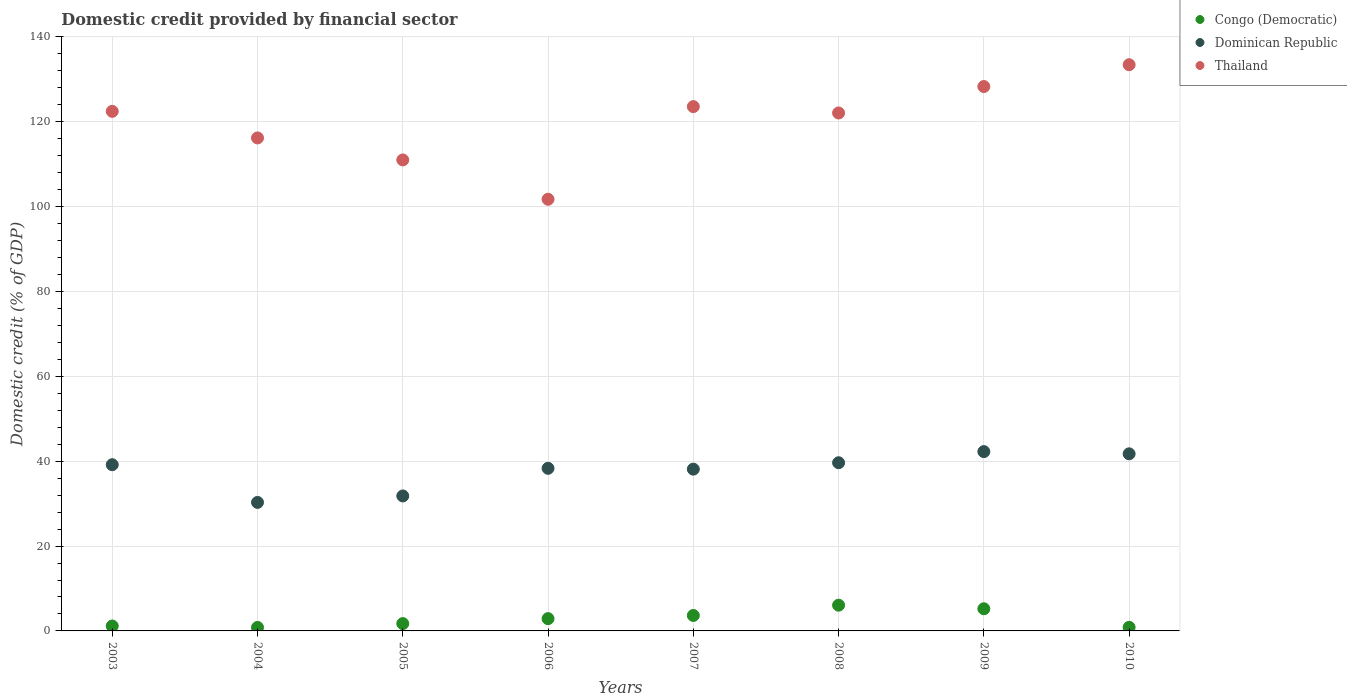What is the domestic credit in Thailand in 2003?
Your answer should be very brief. 122.47. Across all years, what is the maximum domestic credit in Dominican Republic?
Keep it short and to the point. 42.27. Across all years, what is the minimum domestic credit in Congo (Democratic)?
Offer a terse response. 0.82. In which year was the domestic credit in Thailand maximum?
Keep it short and to the point. 2010. In which year was the domestic credit in Dominican Republic minimum?
Your answer should be very brief. 2004. What is the total domestic credit in Dominican Republic in the graph?
Give a very brief answer. 301.4. What is the difference between the domestic credit in Thailand in 2008 and that in 2009?
Your answer should be very brief. -6.23. What is the difference between the domestic credit in Dominican Republic in 2003 and the domestic credit in Congo (Democratic) in 2009?
Keep it short and to the point. 33.95. What is the average domestic credit in Dominican Republic per year?
Keep it short and to the point. 37.68. In the year 2007, what is the difference between the domestic credit in Thailand and domestic credit in Dominican Republic?
Provide a short and direct response. 85.46. What is the ratio of the domestic credit in Thailand in 2007 to that in 2008?
Give a very brief answer. 1.01. Is the domestic credit in Thailand in 2007 less than that in 2008?
Make the answer very short. No. Is the difference between the domestic credit in Thailand in 2007 and 2009 greater than the difference between the domestic credit in Dominican Republic in 2007 and 2009?
Offer a terse response. No. What is the difference between the highest and the second highest domestic credit in Thailand?
Keep it short and to the point. 5.14. What is the difference between the highest and the lowest domestic credit in Congo (Democratic)?
Provide a succinct answer. 5.24. In how many years, is the domestic credit in Thailand greater than the average domestic credit in Thailand taken over all years?
Offer a very short reply. 5. Does the domestic credit in Congo (Democratic) monotonically increase over the years?
Give a very brief answer. No. How many dotlines are there?
Make the answer very short. 3. How many years are there in the graph?
Your answer should be very brief. 8. What is the title of the graph?
Your response must be concise. Domestic credit provided by financial sector. What is the label or title of the X-axis?
Keep it short and to the point. Years. What is the label or title of the Y-axis?
Your response must be concise. Domestic credit (% of GDP). What is the Domestic credit (% of GDP) of Congo (Democratic) in 2003?
Offer a very short reply. 1.16. What is the Domestic credit (% of GDP) of Dominican Republic in 2003?
Ensure brevity in your answer.  39.18. What is the Domestic credit (% of GDP) in Thailand in 2003?
Give a very brief answer. 122.47. What is the Domestic credit (% of GDP) in Congo (Democratic) in 2004?
Your answer should be compact. 0.82. What is the Domestic credit (% of GDP) in Dominican Republic in 2004?
Your answer should be compact. 30.29. What is the Domestic credit (% of GDP) in Thailand in 2004?
Keep it short and to the point. 116.21. What is the Domestic credit (% of GDP) in Congo (Democratic) in 2005?
Your answer should be very brief. 1.73. What is the Domestic credit (% of GDP) of Dominican Republic in 2005?
Offer a very short reply. 31.81. What is the Domestic credit (% of GDP) in Thailand in 2005?
Keep it short and to the point. 111.02. What is the Domestic credit (% of GDP) of Congo (Democratic) in 2006?
Offer a very short reply. 2.9. What is the Domestic credit (% of GDP) in Dominican Republic in 2006?
Offer a terse response. 38.33. What is the Domestic credit (% of GDP) of Thailand in 2006?
Provide a short and direct response. 101.75. What is the Domestic credit (% of GDP) in Congo (Democratic) in 2007?
Provide a short and direct response. 3.64. What is the Domestic credit (% of GDP) in Dominican Republic in 2007?
Give a very brief answer. 38.13. What is the Domestic credit (% of GDP) of Thailand in 2007?
Provide a short and direct response. 123.59. What is the Domestic credit (% of GDP) of Congo (Democratic) in 2008?
Your answer should be very brief. 6.06. What is the Domestic credit (% of GDP) in Dominican Republic in 2008?
Offer a very short reply. 39.64. What is the Domestic credit (% of GDP) of Thailand in 2008?
Your response must be concise. 122.09. What is the Domestic credit (% of GDP) of Congo (Democratic) in 2009?
Provide a succinct answer. 5.22. What is the Domestic credit (% of GDP) of Dominican Republic in 2009?
Ensure brevity in your answer.  42.27. What is the Domestic credit (% of GDP) in Thailand in 2009?
Provide a succinct answer. 128.32. What is the Domestic credit (% of GDP) of Congo (Democratic) in 2010?
Offer a very short reply. 0.85. What is the Domestic credit (% of GDP) of Dominican Republic in 2010?
Offer a very short reply. 41.74. What is the Domestic credit (% of GDP) of Thailand in 2010?
Your answer should be very brief. 133.46. Across all years, what is the maximum Domestic credit (% of GDP) in Congo (Democratic)?
Your answer should be compact. 6.06. Across all years, what is the maximum Domestic credit (% of GDP) of Dominican Republic?
Provide a short and direct response. 42.27. Across all years, what is the maximum Domestic credit (% of GDP) in Thailand?
Provide a short and direct response. 133.46. Across all years, what is the minimum Domestic credit (% of GDP) in Congo (Democratic)?
Provide a short and direct response. 0.82. Across all years, what is the minimum Domestic credit (% of GDP) of Dominican Republic?
Ensure brevity in your answer.  30.29. Across all years, what is the minimum Domestic credit (% of GDP) of Thailand?
Provide a short and direct response. 101.75. What is the total Domestic credit (% of GDP) of Congo (Democratic) in the graph?
Offer a terse response. 22.39. What is the total Domestic credit (% of GDP) of Dominican Republic in the graph?
Offer a terse response. 301.4. What is the total Domestic credit (% of GDP) of Thailand in the graph?
Ensure brevity in your answer.  958.91. What is the difference between the Domestic credit (% of GDP) of Congo (Democratic) in 2003 and that in 2004?
Make the answer very short. 0.34. What is the difference between the Domestic credit (% of GDP) of Dominican Republic in 2003 and that in 2004?
Offer a terse response. 8.89. What is the difference between the Domestic credit (% of GDP) in Thailand in 2003 and that in 2004?
Offer a terse response. 6.27. What is the difference between the Domestic credit (% of GDP) of Congo (Democratic) in 2003 and that in 2005?
Keep it short and to the point. -0.57. What is the difference between the Domestic credit (% of GDP) in Dominican Republic in 2003 and that in 2005?
Keep it short and to the point. 7.36. What is the difference between the Domestic credit (% of GDP) in Thailand in 2003 and that in 2005?
Your answer should be compact. 11.45. What is the difference between the Domestic credit (% of GDP) of Congo (Democratic) in 2003 and that in 2006?
Offer a terse response. -1.74. What is the difference between the Domestic credit (% of GDP) of Dominican Republic in 2003 and that in 2006?
Offer a terse response. 0.85. What is the difference between the Domestic credit (% of GDP) of Thailand in 2003 and that in 2006?
Make the answer very short. 20.72. What is the difference between the Domestic credit (% of GDP) of Congo (Democratic) in 2003 and that in 2007?
Give a very brief answer. -2.48. What is the difference between the Domestic credit (% of GDP) of Dominican Republic in 2003 and that in 2007?
Make the answer very short. 1.04. What is the difference between the Domestic credit (% of GDP) of Thailand in 2003 and that in 2007?
Your answer should be very brief. -1.12. What is the difference between the Domestic credit (% of GDP) of Congo (Democratic) in 2003 and that in 2008?
Offer a terse response. -4.9. What is the difference between the Domestic credit (% of GDP) in Dominican Republic in 2003 and that in 2008?
Ensure brevity in your answer.  -0.47. What is the difference between the Domestic credit (% of GDP) of Thailand in 2003 and that in 2008?
Provide a short and direct response. 0.38. What is the difference between the Domestic credit (% of GDP) of Congo (Democratic) in 2003 and that in 2009?
Provide a short and direct response. -4.06. What is the difference between the Domestic credit (% of GDP) in Dominican Republic in 2003 and that in 2009?
Offer a terse response. -3.09. What is the difference between the Domestic credit (% of GDP) of Thailand in 2003 and that in 2009?
Give a very brief answer. -5.85. What is the difference between the Domestic credit (% of GDP) in Congo (Democratic) in 2003 and that in 2010?
Your answer should be compact. 0.31. What is the difference between the Domestic credit (% of GDP) of Dominican Republic in 2003 and that in 2010?
Make the answer very short. -2.57. What is the difference between the Domestic credit (% of GDP) of Thailand in 2003 and that in 2010?
Your answer should be compact. -10.99. What is the difference between the Domestic credit (% of GDP) of Congo (Democratic) in 2004 and that in 2005?
Make the answer very short. -0.9. What is the difference between the Domestic credit (% of GDP) in Dominican Republic in 2004 and that in 2005?
Your answer should be very brief. -1.52. What is the difference between the Domestic credit (% of GDP) in Thailand in 2004 and that in 2005?
Your answer should be compact. 5.19. What is the difference between the Domestic credit (% of GDP) in Congo (Democratic) in 2004 and that in 2006?
Your response must be concise. -2.07. What is the difference between the Domestic credit (% of GDP) in Dominican Republic in 2004 and that in 2006?
Your answer should be compact. -8.04. What is the difference between the Domestic credit (% of GDP) of Thailand in 2004 and that in 2006?
Your response must be concise. 14.46. What is the difference between the Domestic credit (% of GDP) in Congo (Democratic) in 2004 and that in 2007?
Ensure brevity in your answer.  -2.82. What is the difference between the Domestic credit (% of GDP) in Dominican Republic in 2004 and that in 2007?
Your response must be concise. -7.84. What is the difference between the Domestic credit (% of GDP) of Thailand in 2004 and that in 2007?
Provide a short and direct response. -7.38. What is the difference between the Domestic credit (% of GDP) in Congo (Democratic) in 2004 and that in 2008?
Provide a short and direct response. -5.24. What is the difference between the Domestic credit (% of GDP) in Dominican Republic in 2004 and that in 2008?
Your answer should be very brief. -9.35. What is the difference between the Domestic credit (% of GDP) of Thailand in 2004 and that in 2008?
Make the answer very short. -5.88. What is the difference between the Domestic credit (% of GDP) in Congo (Democratic) in 2004 and that in 2009?
Ensure brevity in your answer.  -4.4. What is the difference between the Domestic credit (% of GDP) of Dominican Republic in 2004 and that in 2009?
Provide a succinct answer. -11.98. What is the difference between the Domestic credit (% of GDP) of Thailand in 2004 and that in 2009?
Provide a short and direct response. -12.12. What is the difference between the Domestic credit (% of GDP) of Congo (Democratic) in 2004 and that in 2010?
Your answer should be very brief. -0.03. What is the difference between the Domestic credit (% of GDP) in Dominican Republic in 2004 and that in 2010?
Your answer should be compact. -11.45. What is the difference between the Domestic credit (% of GDP) in Thailand in 2004 and that in 2010?
Keep it short and to the point. -17.26. What is the difference between the Domestic credit (% of GDP) in Congo (Democratic) in 2005 and that in 2006?
Ensure brevity in your answer.  -1.17. What is the difference between the Domestic credit (% of GDP) in Dominican Republic in 2005 and that in 2006?
Keep it short and to the point. -6.52. What is the difference between the Domestic credit (% of GDP) in Thailand in 2005 and that in 2006?
Keep it short and to the point. 9.27. What is the difference between the Domestic credit (% of GDP) of Congo (Democratic) in 2005 and that in 2007?
Ensure brevity in your answer.  -1.91. What is the difference between the Domestic credit (% of GDP) in Dominican Republic in 2005 and that in 2007?
Offer a terse response. -6.32. What is the difference between the Domestic credit (% of GDP) in Thailand in 2005 and that in 2007?
Keep it short and to the point. -12.57. What is the difference between the Domestic credit (% of GDP) in Congo (Democratic) in 2005 and that in 2008?
Make the answer very short. -4.34. What is the difference between the Domestic credit (% of GDP) of Dominican Republic in 2005 and that in 2008?
Offer a terse response. -7.83. What is the difference between the Domestic credit (% of GDP) of Thailand in 2005 and that in 2008?
Give a very brief answer. -11.07. What is the difference between the Domestic credit (% of GDP) in Congo (Democratic) in 2005 and that in 2009?
Offer a very short reply. -3.49. What is the difference between the Domestic credit (% of GDP) of Dominican Republic in 2005 and that in 2009?
Offer a terse response. -10.45. What is the difference between the Domestic credit (% of GDP) of Thailand in 2005 and that in 2009?
Give a very brief answer. -17.3. What is the difference between the Domestic credit (% of GDP) of Congo (Democratic) in 2005 and that in 2010?
Your answer should be very brief. 0.88. What is the difference between the Domestic credit (% of GDP) in Dominican Republic in 2005 and that in 2010?
Offer a terse response. -9.93. What is the difference between the Domestic credit (% of GDP) of Thailand in 2005 and that in 2010?
Give a very brief answer. -22.45. What is the difference between the Domestic credit (% of GDP) in Congo (Democratic) in 2006 and that in 2007?
Give a very brief answer. -0.75. What is the difference between the Domestic credit (% of GDP) of Dominican Republic in 2006 and that in 2007?
Give a very brief answer. 0.2. What is the difference between the Domestic credit (% of GDP) of Thailand in 2006 and that in 2007?
Offer a terse response. -21.84. What is the difference between the Domestic credit (% of GDP) of Congo (Democratic) in 2006 and that in 2008?
Provide a succinct answer. -3.17. What is the difference between the Domestic credit (% of GDP) of Dominican Republic in 2006 and that in 2008?
Your answer should be very brief. -1.31. What is the difference between the Domestic credit (% of GDP) in Thailand in 2006 and that in 2008?
Give a very brief answer. -20.34. What is the difference between the Domestic credit (% of GDP) of Congo (Democratic) in 2006 and that in 2009?
Provide a succinct answer. -2.33. What is the difference between the Domestic credit (% of GDP) of Dominican Republic in 2006 and that in 2009?
Make the answer very short. -3.93. What is the difference between the Domestic credit (% of GDP) in Thailand in 2006 and that in 2009?
Your answer should be compact. -26.57. What is the difference between the Domestic credit (% of GDP) in Congo (Democratic) in 2006 and that in 2010?
Provide a short and direct response. 2.05. What is the difference between the Domestic credit (% of GDP) in Dominican Republic in 2006 and that in 2010?
Offer a terse response. -3.41. What is the difference between the Domestic credit (% of GDP) of Thailand in 2006 and that in 2010?
Offer a very short reply. -31.71. What is the difference between the Domestic credit (% of GDP) in Congo (Democratic) in 2007 and that in 2008?
Make the answer very short. -2.42. What is the difference between the Domestic credit (% of GDP) of Dominican Republic in 2007 and that in 2008?
Offer a very short reply. -1.51. What is the difference between the Domestic credit (% of GDP) in Thailand in 2007 and that in 2008?
Offer a very short reply. 1.5. What is the difference between the Domestic credit (% of GDP) in Congo (Democratic) in 2007 and that in 2009?
Offer a very short reply. -1.58. What is the difference between the Domestic credit (% of GDP) in Dominican Republic in 2007 and that in 2009?
Your answer should be compact. -4.13. What is the difference between the Domestic credit (% of GDP) of Thailand in 2007 and that in 2009?
Give a very brief answer. -4.73. What is the difference between the Domestic credit (% of GDP) in Congo (Democratic) in 2007 and that in 2010?
Your answer should be very brief. 2.79. What is the difference between the Domestic credit (% of GDP) in Dominican Republic in 2007 and that in 2010?
Provide a succinct answer. -3.61. What is the difference between the Domestic credit (% of GDP) of Thailand in 2007 and that in 2010?
Keep it short and to the point. -9.87. What is the difference between the Domestic credit (% of GDP) of Congo (Democratic) in 2008 and that in 2009?
Provide a succinct answer. 0.84. What is the difference between the Domestic credit (% of GDP) in Dominican Republic in 2008 and that in 2009?
Keep it short and to the point. -2.62. What is the difference between the Domestic credit (% of GDP) of Thailand in 2008 and that in 2009?
Make the answer very short. -6.23. What is the difference between the Domestic credit (% of GDP) in Congo (Democratic) in 2008 and that in 2010?
Offer a terse response. 5.21. What is the difference between the Domestic credit (% of GDP) of Dominican Republic in 2008 and that in 2010?
Ensure brevity in your answer.  -2.1. What is the difference between the Domestic credit (% of GDP) of Thailand in 2008 and that in 2010?
Give a very brief answer. -11.37. What is the difference between the Domestic credit (% of GDP) of Congo (Democratic) in 2009 and that in 2010?
Ensure brevity in your answer.  4.37. What is the difference between the Domestic credit (% of GDP) of Dominican Republic in 2009 and that in 2010?
Make the answer very short. 0.52. What is the difference between the Domestic credit (% of GDP) in Thailand in 2009 and that in 2010?
Your answer should be compact. -5.14. What is the difference between the Domestic credit (% of GDP) in Congo (Democratic) in 2003 and the Domestic credit (% of GDP) in Dominican Republic in 2004?
Keep it short and to the point. -29.13. What is the difference between the Domestic credit (% of GDP) of Congo (Democratic) in 2003 and the Domestic credit (% of GDP) of Thailand in 2004?
Offer a very short reply. -115.05. What is the difference between the Domestic credit (% of GDP) of Dominican Republic in 2003 and the Domestic credit (% of GDP) of Thailand in 2004?
Ensure brevity in your answer.  -77.03. What is the difference between the Domestic credit (% of GDP) of Congo (Democratic) in 2003 and the Domestic credit (% of GDP) of Dominican Republic in 2005?
Provide a short and direct response. -30.65. What is the difference between the Domestic credit (% of GDP) of Congo (Democratic) in 2003 and the Domestic credit (% of GDP) of Thailand in 2005?
Your answer should be very brief. -109.86. What is the difference between the Domestic credit (% of GDP) in Dominican Republic in 2003 and the Domestic credit (% of GDP) in Thailand in 2005?
Ensure brevity in your answer.  -71.84. What is the difference between the Domestic credit (% of GDP) in Congo (Democratic) in 2003 and the Domestic credit (% of GDP) in Dominican Republic in 2006?
Provide a short and direct response. -37.17. What is the difference between the Domestic credit (% of GDP) of Congo (Democratic) in 2003 and the Domestic credit (% of GDP) of Thailand in 2006?
Make the answer very short. -100.59. What is the difference between the Domestic credit (% of GDP) in Dominican Republic in 2003 and the Domestic credit (% of GDP) in Thailand in 2006?
Your response must be concise. -62.57. What is the difference between the Domestic credit (% of GDP) in Congo (Democratic) in 2003 and the Domestic credit (% of GDP) in Dominican Republic in 2007?
Provide a succinct answer. -36.97. What is the difference between the Domestic credit (% of GDP) in Congo (Democratic) in 2003 and the Domestic credit (% of GDP) in Thailand in 2007?
Your response must be concise. -122.43. What is the difference between the Domestic credit (% of GDP) in Dominican Republic in 2003 and the Domestic credit (% of GDP) in Thailand in 2007?
Your answer should be compact. -84.41. What is the difference between the Domestic credit (% of GDP) of Congo (Democratic) in 2003 and the Domestic credit (% of GDP) of Dominican Republic in 2008?
Your response must be concise. -38.48. What is the difference between the Domestic credit (% of GDP) of Congo (Democratic) in 2003 and the Domestic credit (% of GDP) of Thailand in 2008?
Provide a succinct answer. -120.93. What is the difference between the Domestic credit (% of GDP) of Dominican Republic in 2003 and the Domestic credit (% of GDP) of Thailand in 2008?
Ensure brevity in your answer.  -82.91. What is the difference between the Domestic credit (% of GDP) of Congo (Democratic) in 2003 and the Domestic credit (% of GDP) of Dominican Republic in 2009?
Provide a short and direct response. -41.11. What is the difference between the Domestic credit (% of GDP) in Congo (Democratic) in 2003 and the Domestic credit (% of GDP) in Thailand in 2009?
Make the answer very short. -127.16. What is the difference between the Domestic credit (% of GDP) of Dominican Republic in 2003 and the Domestic credit (% of GDP) of Thailand in 2009?
Ensure brevity in your answer.  -89.14. What is the difference between the Domestic credit (% of GDP) in Congo (Democratic) in 2003 and the Domestic credit (% of GDP) in Dominican Republic in 2010?
Your answer should be very brief. -40.58. What is the difference between the Domestic credit (% of GDP) of Congo (Democratic) in 2003 and the Domestic credit (% of GDP) of Thailand in 2010?
Keep it short and to the point. -132.3. What is the difference between the Domestic credit (% of GDP) in Dominican Republic in 2003 and the Domestic credit (% of GDP) in Thailand in 2010?
Your response must be concise. -94.29. What is the difference between the Domestic credit (% of GDP) of Congo (Democratic) in 2004 and the Domestic credit (% of GDP) of Dominican Republic in 2005?
Ensure brevity in your answer.  -30.99. What is the difference between the Domestic credit (% of GDP) in Congo (Democratic) in 2004 and the Domestic credit (% of GDP) in Thailand in 2005?
Your response must be concise. -110.19. What is the difference between the Domestic credit (% of GDP) of Dominican Republic in 2004 and the Domestic credit (% of GDP) of Thailand in 2005?
Offer a terse response. -80.73. What is the difference between the Domestic credit (% of GDP) in Congo (Democratic) in 2004 and the Domestic credit (% of GDP) in Dominican Republic in 2006?
Provide a short and direct response. -37.51. What is the difference between the Domestic credit (% of GDP) of Congo (Democratic) in 2004 and the Domestic credit (% of GDP) of Thailand in 2006?
Provide a succinct answer. -100.93. What is the difference between the Domestic credit (% of GDP) of Dominican Republic in 2004 and the Domestic credit (% of GDP) of Thailand in 2006?
Offer a very short reply. -71.46. What is the difference between the Domestic credit (% of GDP) in Congo (Democratic) in 2004 and the Domestic credit (% of GDP) in Dominican Republic in 2007?
Your answer should be very brief. -37.31. What is the difference between the Domestic credit (% of GDP) of Congo (Democratic) in 2004 and the Domestic credit (% of GDP) of Thailand in 2007?
Give a very brief answer. -122.77. What is the difference between the Domestic credit (% of GDP) of Dominican Republic in 2004 and the Domestic credit (% of GDP) of Thailand in 2007?
Keep it short and to the point. -93.3. What is the difference between the Domestic credit (% of GDP) in Congo (Democratic) in 2004 and the Domestic credit (% of GDP) in Dominican Republic in 2008?
Ensure brevity in your answer.  -38.82. What is the difference between the Domestic credit (% of GDP) in Congo (Democratic) in 2004 and the Domestic credit (% of GDP) in Thailand in 2008?
Your answer should be very brief. -121.27. What is the difference between the Domestic credit (% of GDP) of Dominican Republic in 2004 and the Domestic credit (% of GDP) of Thailand in 2008?
Offer a very short reply. -91.8. What is the difference between the Domestic credit (% of GDP) in Congo (Democratic) in 2004 and the Domestic credit (% of GDP) in Dominican Republic in 2009?
Make the answer very short. -41.44. What is the difference between the Domestic credit (% of GDP) in Congo (Democratic) in 2004 and the Domestic credit (% of GDP) in Thailand in 2009?
Offer a terse response. -127.5. What is the difference between the Domestic credit (% of GDP) in Dominican Republic in 2004 and the Domestic credit (% of GDP) in Thailand in 2009?
Your response must be concise. -98.03. What is the difference between the Domestic credit (% of GDP) of Congo (Democratic) in 2004 and the Domestic credit (% of GDP) of Dominican Republic in 2010?
Your answer should be compact. -40.92. What is the difference between the Domestic credit (% of GDP) of Congo (Democratic) in 2004 and the Domestic credit (% of GDP) of Thailand in 2010?
Provide a succinct answer. -132.64. What is the difference between the Domestic credit (% of GDP) of Dominican Republic in 2004 and the Domestic credit (% of GDP) of Thailand in 2010?
Ensure brevity in your answer.  -103.17. What is the difference between the Domestic credit (% of GDP) in Congo (Democratic) in 2005 and the Domestic credit (% of GDP) in Dominican Republic in 2006?
Ensure brevity in your answer.  -36.6. What is the difference between the Domestic credit (% of GDP) in Congo (Democratic) in 2005 and the Domestic credit (% of GDP) in Thailand in 2006?
Provide a succinct answer. -100.02. What is the difference between the Domestic credit (% of GDP) in Dominican Republic in 2005 and the Domestic credit (% of GDP) in Thailand in 2006?
Provide a succinct answer. -69.93. What is the difference between the Domestic credit (% of GDP) in Congo (Democratic) in 2005 and the Domestic credit (% of GDP) in Dominican Republic in 2007?
Your answer should be very brief. -36.4. What is the difference between the Domestic credit (% of GDP) in Congo (Democratic) in 2005 and the Domestic credit (% of GDP) in Thailand in 2007?
Keep it short and to the point. -121.86. What is the difference between the Domestic credit (% of GDP) of Dominican Republic in 2005 and the Domestic credit (% of GDP) of Thailand in 2007?
Make the answer very short. -91.78. What is the difference between the Domestic credit (% of GDP) in Congo (Democratic) in 2005 and the Domestic credit (% of GDP) in Dominican Republic in 2008?
Your answer should be very brief. -37.92. What is the difference between the Domestic credit (% of GDP) in Congo (Democratic) in 2005 and the Domestic credit (% of GDP) in Thailand in 2008?
Offer a very short reply. -120.36. What is the difference between the Domestic credit (% of GDP) of Dominican Republic in 2005 and the Domestic credit (% of GDP) of Thailand in 2008?
Offer a terse response. -90.28. What is the difference between the Domestic credit (% of GDP) of Congo (Democratic) in 2005 and the Domestic credit (% of GDP) of Dominican Republic in 2009?
Give a very brief answer. -40.54. What is the difference between the Domestic credit (% of GDP) of Congo (Democratic) in 2005 and the Domestic credit (% of GDP) of Thailand in 2009?
Your response must be concise. -126.59. What is the difference between the Domestic credit (% of GDP) of Dominican Republic in 2005 and the Domestic credit (% of GDP) of Thailand in 2009?
Ensure brevity in your answer.  -96.51. What is the difference between the Domestic credit (% of GDP) of Congo (Democratic) in 2005 and the Domestic credit (% of GDP) of Dominican Republic in 2010?
Provide a short and direct response. -40.02. What is the difference between the Domestic credit (% of GDP) in Congo (Democratic) in 2005 and the Domestic credit (% of GDP) in Thailand in 2010?
Offer a very short reply. -131.74. What is the difference between the Domestic credit (% of GDP) of Dominican Republic in 2005 and the Domestic credit (% of GDP) of Thailand in 2010?
Offer a very short reply. -101.65. What is the difference between the Domestic credit (% of GDP) of Congo (Democratic) in 2006 and the Domestic credit (% of GDP) of Dominican Republic in 2007?
Your answer should be compact. -35.24. What is the difference between the Domestic credit (% of GDP) of Congo (Democratic) in 2006 and the Domestic credit (% of GDP) of Thailand in 2007?
Ensure brevity in your answer.  -120.7. What is the difference between the Domestic credit (% of GDP) in Dominican Republic in 2006 and the Domestic credit (% of GDP) in Thailand in 2007?
Ensure brevity in your answer.  -85.26. What is the difference between the Domestic credit (% of GDP) in Congo (Democratic) in 2006 and the Domestic credit (% of GDP) in Dominican Republic in 2008?
Provide a succinct answer. -36.75. What is the difference between the Domestic credit (% of GDP) in Congo (Democratic) in 2006 and the Domestic credit (% of GDP) in Thailand in 2008?
Your response must be concise. -119.19. What is the difference between the Domestic credit (% of GDP) in Dominican Republic in 2006 and the Domestic credit (% of GDP) in Thailand in 2008?
Keep it short and to the point. -83.76. What is the difference between the Domestic credit (% of GDP) in Congo (Democratic) in 2006 and the Domestic credit (% of GDP) in Dominican Republic in 2009?
Your answer should be very brief. -39.37. What is the difference between the Domestic credit (% of GDP) in Congo (Democratic) in 2006 and the Domestic credit (% of GDP) in Thailand in 2009?
Provide a succinct answer. -125.43. What is the difference between the Domestic credit (% of GDP) of Dominican Republic in 2006 and the Domestic credit (% of GDP) of Thailand in 2009?
Make the answer very short. -89.99. What is the difference between the Domestic credit (% of GDP) in Congo (Democratic) in 2006 and the Domestic credit (% of GDP) in Dominican Republic in 2010?
Ensure brevity in your answer.  -38.85. What is the difference between the Domestic credit (% of GDP) in Congo (Democratic) in 2006 and the Domestic credit (% of GDP) in Thailand in 2010?
Make the answer very short. -130.57. What is the difference between the Domestic credit (% of GDP) in Dominican Republic in 2006 and the Domestic credit (% of GDP) in Thailand in 2010?
Give a very brief answer. -95.13. What is the difference between the Domestic credit (% of GDP) of Congo (Democratic) in 2007 and the Domestic credit (% of GDP) of Dominican Republic in 2008?
Ensure brevity in your answer.  -36. What is the difference between the Domestic credit (% of GDP) of Congo (Democratic) in 2007 and the Domestic credit (% of GDP) of Thailand in 2008?
Your answer should be very brief. -118.45. What is the difference between the Domestic credit (% of GDP) of Dominican Republic in 2007 and the Domestic credit (% of GDP) of Thailand in 2008?
Keep it short and to the point. -83.96. What is the difference between the Domestic credit (% of GDP) in Congo (Democratic) in 2007 and the Domestic credit (% of GDP) in Dominican Republic in 2009?
Make the answer very short. -38.63. What is the difference between the Domestic credit (% of GDP) of Congo (Democratic) in 2007 and the Domestic credit (% of GDP) of Thailand in 2009?
Make the answer very short. -124.68. What is the difference between the Domestic credit (% of GDP) in Dominican Republic in 2007 and the Domestic credit (% of GDP) in Thailand in 2009?
Give a very brief answer. -90.19. What is the difference between the Domestic credit (% of GDP) of Congo (Democratic) in 2007 and the Domestic credit (% of GDP) of Dominican Republic in 2010?
Provide a succinct answer. -38.1. What is the difference between the Domestic credit (% of GDP) in Congo (Democratic) in 2007 and the Domestic credit (% of GDP) in Thailand in 2010?
Offer a very short reply. -129.82. What is the difference between the Domestic credit (% of GDP) in Dominican Republic in 2007 and the Domestic credit (% of GDP) in Thailand in 2010?
Your response must be concise. -95.33. What is the difference between the Domestic credit (% of GDP) of Congo (Democratic) in 2008 and the Domestic credit (% of GDP) of Dominican Republic in 2009?
Ensure brevity in your answer.  -36.2. What is the difference between the Domestic credit (% of GDP) of Congo (Democratic) in 2008 and the Domestic credit (% of GDP) of Thailand in 2009?
Your response must be concise. -122.26. What is the difference between the Domestic credit (% of GDP) of Dominican Republic in 2008 and the Domestic credit (% of GDP) of Thailand in 2009?
Keep it short and to the point. -88.68. What is the difference between the Domestic credit (% of GDP) in Congo (Democratic) in 2008 and the Domestic credit (% of GDP) in Dominican Republic in 2010?
Provide a short and direct response. -35.68. What is the difference between the Domestic credit (% of GDP) of Congo (Democratic) in 2008 and the Domestic credit (% of GDP) of Thailand in 2010?
Your answer should be compact. -127.4. What is the difference between the Domestic credit (% of GDP) of Dominican Republic in 2008 and the Domestic credit (% of GDP) of Thailand in 2010?
Your answer should be compact. -93.82. What is the difference between the Domestic credit (% of GDP) in Congo (Democratic) in 2009 and the Domestic credit (% of GDP) in Dominican Republic in 2010?
Keep it short and to the point. -36.52. What is the difference between the Domestic credit (% of GDP) of Congo (Democratic) in 2009 and the Domestic credit (% of GDP) of Thailand in 2010?
Give a very brief answer. -128.24. What is the difference between the Domestic credit (% of GDP) in Dominican Republic in 2009 and the Domestic credit (% of GDP) in Thailand in 2010?
Make the answer very short. -91.2. What is the average Domestic credit (% of GDP) in Congo (Democratic) per year?
Your answer should be very brief. 2.8. What is the average Domestic credit (% of GDP) in Dominican Republic per year?
Your answer should be very brief. 37.68. What is the average Domestic credit (% of GDP) of Thailand per year?
Offer a very short reply. 119.86. In the year 2003, what is the difference between the Domestic credit (% of GDP) of Congo (Democratic) and Domestic credit (% of GDP) of Dominican Republic?
Keep it short and to the point. -38.02. In the year 2003, what is the difference between the Domestic credit (% of GDP) in Congo (Democratic) and Domestic credit (% of GDP) in Thailand?
Provide a succinct answer. -121.31. In the year 2003, what is the difference between the Domestic credit (% of GDP) in Dominican Republic and Domestic credit (% of GDP) in Thailand?
Offer a terse response. -83.29. In the year 2004, what is the difference between the Domestic credit (% of GDP) in Congo (Democratic) and Domestic credit (% of GDP) in Dominican Republic?
Your answer should be very brief. -29.47. In the year 2004, what is the difference between the Domestic credit (% of GDP) of Congo (Democratic) and Domestic credit (% of GDP) of Thailand?
Your response must be concise. -115.38. In the year 2004, what is the difference between the Domestic credit (% of GDP) in Dominican Republic and Domestic credit (% of GDP) in Thailand?
Your answer should be compact. -85.91. In the year 2005, what is the difference between the Domestic credit (% of GDP) of Congo (Democratic) and Domestic credit (% of GDP) of Dominican Republic?
Ensure brevity in your answer.  -30.09. In the year 2005, what is the difference between the Domestic credit (% of GDP) in Congo (Democratic) and Domestic credit (% of GDP) in Thailand?
Offer a terse response. -109.29. In the year 2005, what is the difference between the Domestic credit (% of GDP) in Dominican Republic and Domestic credit (% of GDP) in Thailand?
Make the answer very short. -79.2. In the year 2006, what is the difference between the Domestic credit (% of GDP) of Congo (Democratic) and Domestic credit (% of GDP) of Dominican Republic?
Provide a short and direct response. -35.44. In the year 2006, what is the difference between the Domestic credit (% of GDP) of Congo (Democratic) and Domestic credit (% of GDP) of Thailand?
Offer a very short reply. -98.85. In the year 2006, what is the difference between the Domestic credit (% of GDP) of Dominican Republic and Domestic credit (% of GDP) of Thailand?
Make the answer very short. -63.42. In the year 2007, what is the difference between the Domestic credit (% of GDP) of Congo (Democratic) and Domestic credit (% of GDP) of Dominican Republic?
Your response must be concise. -34.49. In the year 2007, what is the difference between the Domestic credit (% of GDP) in Congo (Democratic) and Domestic credit (% of GDP) in Thailand?
Ensure brevity in your answer.  -119.95. In the year 2007, what is the difference between the Domestic credit (% of GDP) in Dominican Republic and Domestic credit (% of GDP) in Thailand?
Offer a terse response. -85.46. In the year 2008, what is the difference between the Domestic credit (% of GDP) in Congo (Democratic) and Domestic credit (% of GDP) in Dominican Republic?
Provide a succinct answer. -33.58. In the year 2008, what is the difference between the Domestic credit (% of GDP) of Congo (Democratic) and Domestic credit (% of GDP) of Thailand?
Offer a very short reply. -116.03. In the year 2008, what is the difference between the Domestic credit (% of GDP) of Dominican Republic and Domestic credit (% of GDP) of Thailand?
Ensure brevity in your answer.  -82.45. In the year 2009, what is the difference between the Domestic credit (% of GDP) in Congo (Democratic) and Domestic credit (% of GDP) in Dominican Republic?
Ensure brevity in your answer.  -37.04. In the year 2009, what is the difference between the Domestic credit (% of GDP) of Congo (Democratic) and Domestic credit (% of GDP) of Thailand?
Ensure brevity in your answer.  -123.1. In the year 2009, what is the difference between the Domestic credit (% of GDP) in Dominican Republic and Domestic credit (% of GDP) in Thailand?
Ensure brevity in your answer.  -86.06. In the year 2010, what is the difference between the Domestic credit (% of GDP) in Congo (Democratic) and Domestic credit (% of GDP) in Dominican Republic?
Offer a terse response. -40.89. In the year 2010, what is the difference between the Domestic credit (% of GDP) in Congo (Democratic) and Domestic credit (% of GDP) in Thailand?
Your answer should be very brief. -132.61. In the year 2010, what is the difference between the Domestic credit (% of GDP) of Dominican Republic and Domestic credit (% of GDP) of Thailand?
Your response must be concise. -91.72. What is the ratio of the Domestic credit (% of GDP) in Congo (Democratic) in 2003 to that in 2004?
Offer a very short reply. 1.41. What is the ratio of the Domestic credit (% of GDP) in Dominican Republic in 2003 to that in 2004?
Your answer should be compact. 1.29. What is the ratio of the Domestic credit (% of GDP) of Thailand in 2003 to that in 2004?
Keep it short and to the point. 1.05. What is the ratio of the Domestic credit (% of GDP) of Congo (Democratic) in 2003 to that in 2005?
Give a very brief answer. 0.67. What is the ratio of the Domestic credit (% of GDP) of Dominican Republic in 2003 to that in 2005?
Provide a succinct answer. 1.23. What is the ratio of the Domestic credit (% of GDP) of Thailand in 2003 to that in 2005?
Offer a very short reply. 1.1. What is the ratio of the Domestic credit (% of GDP) of Congo (Democratic) in 2003 to that in 2006?
Your answer should be compact. 0.4. What is the ratio of the Domestic credit (% of GDP) of Dominican Republic in 2003 to that in 2006?
Ensure brevity in your answer.  1.02. What is the ratio of the Domestic credit (% of GDP) of Thailand in 2003 to that in 2006?
Your answer should be compact. 1.2. What is the ratio of the Domestic credit (% of GDP) in Congo (Democratic) in 2003 to that in 2007?
Provide a succinct answer. 0.32. What is the ratio of the Domestic credit (% of GDP) of Dominican Republic in 2003 to that in 2007?
Ensure brevity in your answer.  1.03. What is the ratio of the Domestic credit (% of GDP) in Thailand in 2003 to that in 2007?
Give a very brief answer. 0.99. What is the ratio of the Domestic credit (% of GDP) in Congo (Democratic) in 2003 to that in 2008?
Ensure brevity in your answer.  0.19. What is the ratio of the Domestic credit (% of GDP) of Dominican Republic in 2003 to that in 2008?
Your answer should be very brief. 0.99. What is the ratio of the Domestic credit (% of GDP) in Congo (Democratic) in 2003 to that in 2009?
Your response must be concise. 0.22. What is the ratio of the Domestic credit (% of GDP) of Dominican Republic in 2003 to that in 2009?
Give a very brief answer. 0.93. What is the ratio of the Domestic credit (% of GDP) of Thailand in 2003 to that in 2009?
Offer a terse response. 0.95. What is the ratio of the Domestic credit (% of GDP) of Congo (Democratic) in 2003 to that in 2010?
Your response must be concise. 1.37. What is the ratio of the Domestic credit (% of GDP) in Dominican Republic in 2003 to that in 2010?
Offer a very short reply. 0.94. What is the ratio of the Domestic credit (% of GDP) of Thailand in 2003 to that in 2010?
Make the answer very short. 0.92. What is the ratio of the Domestic credit (% of GDP) in Congo (Democratic) in 2004 to that in 2005?
Your answer should be very brief. 0.48. What is the ratio of the Domestic credit (% of GDP) of Dominican Republic in 2004 to that in 2005?
Your answer should be compact. 0.95. What is the ratio of the Domestic credit (% of GDP) of Thailand in 2004 to that in 2005?
Offer a very short reply. 1.05. What is the ratio of the Domestic credit (% of GDP) of Congo (Democratic) in 2004 to that in 2006?
Your answer should be compact. 0.28. What is the ratio of the Domestic credit (% of GDP) of Dominican Republic in 2004 to that in 2006?
Give a very brief answer. 0.79. What is the ratio of the Domestic credit (% of GDP) of Thailand in 2004 to that in 2006?
Give a very brief answer. 1.14. What is the ratio of the Domestic credit (% of GDP) of Congo (Democratic) in 2004 to that in 2007?
Your answer should be compact. 0.23. What is the ratio of the Domestic credit (% of GDP) of Dominican Republic in 2004 to that in 2007?
Offer a very short reply. 0.79. What is the ratio of the Domestic credit (% of GDP) in Thailand in 2004 to that in 2007?
Provide a succinct answer. 0.94. What is the ratio of the Domestic credit (% of GDP) of Congo (Democratic) in 2004 to that in 2008?
Your answer should be very brief. 0.14. What is the ratio of the Domestic credit (% of GDP) in Dominican Republic in 2004 to that in 2008?
Your answer should be compact. 0.76. What is the ratio of the Domestic credit (% of GDP) of Thailand in 2004 to that in 2008?
Offer a terse response. 0.95. What is the ratio of the Domestic credit (% of GDP) in Congo (Democratic) in 2004 to that in 2009?
Provide a succinct answer. 0.16. What is the ratio of the Domestic credit (% of GDP) in Dominican Republic in 2004 to that in 2009?
Your response must be concise. 0.72. What is the ratio of the Domestic credit (% of GDP) of Thailand in 2004 to that in 2009?
Your response must be concise. 0.91. What is the ratio of the Domestic credit (% of GDP) in Congo (Democratic) in 2004 to that in 2010?
Your answer should be compact. 0.97. What is the ratio of the Domestic credit (% of GDP) in Dominican Republic in 2004 to that in 2010?
Provide a succinct answer. 0.73. What is the ratio of the Domestic credit (% of GDP) of Thailand in 2004 to that in 2010?
Offer a terse response. 0.87. What is the ratio of the Domestic credit (% of GDP) of Congo (Democratic) in 2005 to that in 2006?
Your response must be concise. 0.6. What is the ratio of the Domestic credit (% of GDP) in Dominican Republic in 2005 to that in 2006?
Give a very brief answer. 0.83. What is the ratio of the Domestic credit (% of GDP) of Thailand in 2005 to that in 2006?
Make the answer very short. 1.09. What is the ratio of the Domestic credit (% of GDP) in Congo (Democratic) in 2005 to that in 2007?
Offer a very short reply. 0.47. What is the ratio of the Domestic credit (% of GDP) in Dominican Republic in 2005 to that in 2007?
Your response must be concise. 0.83. What is the ratio of the Domestic credit (% of GDP) of Thailand in 2005 to that in 2007?
Offer a terse response. 0.9. What is the ratio of the Domestic credit (% of GDP) in Congo (Democratic) in 2005 to that in 2008?
Your response must be concise. 0.29. What is the ratio of the Domestic credit (% of GDP) in Dominican Republic in 2005 to that in 2008?
Give a very brief answer. 0.8. What is the ratio of the Domestic credit (% of GDP) of Thailand in 2005 to that in 2008?
Give a very brief answer. 0.91. What is the ratio of the Domestic credit (% of GDP) in Congo (Democratic) in 2005 to that in 2009?
Make the answer very short. 0.33. What is the ratio of the Domestic credit (% of GDP) of Dominican Republic in 2005 to that in 2009?
Make the answer very short. 0.75. What is the ratio of the Domestic credit (% of GDP) of Thailand in 2005 to that in 2009?
Your response must be concise. 0.87. What is the ratio of the Domestic credit (% of GDP) in Congo (Democratic) in 2005 to that in 2010?
Your answer should be compact. 2.03. What is the ratio of the Domestic credit (% of GDP) of Dominican Republic in 2005 to that in 2010?
Your response must be concise. 0.76. What is the ratio of the Domestic credit (% of GDP) in Thailand in 2005 to that in 2010?
Keep it short and to the point. 0.83. What is the ratio of the Domestic credit (% of GDP) in Congo (Democratic) in 2006 to that in 2007?
Offer a terse response. 0.8. What is the ratio of the Domestic credit (% of GDP) in Thailand in 2006 to that in 2007?
Give a very brief answer. 0.82. What is the ratio of the Domestic credit (% of GDP) of Congo (Democratic) in 2006 to that in 2008?
Give a very brief answer. 0.48. What is the ratio of the Domestic credit (% of GDP) of Dominican Republic in 2006 to that in 2008?
Provide a short and direct response. 0.97. What is the ratio of the Domestic credit (% of GDP) in Thailand in 2006 to that in 2008?
Offer a very short reply. 0.83. What is the ratio of the Domestic credit (% of GDP) in Congo (Democratic) in 2006 to that in 2009?
Give a very brief answer. 0.55. What is the ratio of the Domestic credit (% of GDP) in Dominican Republic in 2006 to that in 2009?
Provide a short and direct response. 0.91. What is the ratio of the Domestic credit (% of GDP) in Thailand in 2006 to that in 2009?
Give a very brief answer. 0.79. What is the ratio of the Domestic credit (% of GDP) in Congo (Democratic) in 2006 to that in 2010?
Provide a short and direct response. 3.41. What is the ratio of the Domestic credit (% of GDP) of Dominican Republic in 2006 to that in 2010?
Offer a very short reply. 0.92. What is the ratio of the Domestic credit (% of GDP) of Thailand in 2006 to that in 2010?
Your response must be concise. 0.76. What is the ratio of the Domestic credit (% of GDP) in Congo (Democratic) in 2007 to that in 2008?
Your answer should be compact. 0.6. What is the ratio of the Domestic credit (% of GDP) of Dominican Republic in 2007 to that in 2008?
Make the answer very short. 0.96. What is the ratio of the Domestic credit (% of GDP) in Thailand in 2007 to that in 2008?
Your answer should be compact. 1.01. What is the ratio of the Domestic credit (% of GDP) in Congo (Democratic) in 2007 to that in 2009?
Offer a very short reply. 0.7. What is the ratio of the Domestic credit (% of GDP) of Dominican Republic in 2007 to that in 2009?
Provide a succinct answer. 0.9. What is the ratio of the Domestic credit (% of GDP) of Thailand in 2007 to that in 2009?
Your answer should be compact. 0.96. What is the ratio of the Domestic credit (% of GDP) in Congo (Democratic) in 2007 to that in 2010?
Your response must be concise. 4.29. What is the ratio of the Domestic credit (% of GDP) of Dominican Republic in 2007 to that in 2010?
Keep it short and to the point. 0.91. What is the ratio of the Domestic credit (% of GDP) in Thailand in 2007 to that in 2010?
Offer a terse response. 0.93. What is the ratio of the Domestic credit (% of GDP) in Congo (Democratic) in 2008 to that in 2009?
Provide a succinct answer. 1.16. What is the ratio of the Domestic credit (% of GDP) of Dominican Republic in 2008 to that in 2009?
Provide a short and direct response. 0.94. What is the ratio of the Domestic credit (% of GDP) in Thailand in 2008 to that in 2009?
Offer a terse response. 0.95. What is the ratio of the Domestic credit (% of GDP) of Congo (Democratic) in 2008 to that in 2010?
Make the answer very short. 7.14. What is the ratio of the Domestic credit (% of GDP) in Dominican Republic in 2008 to that in 2010?
Keep it short and to the point. 0.95. What is the ratio of the Domestic credit (% of GDP) of Thailand in 2008 to that in 2010?
Keep it short and to the point. 0.91. What is the ratio of the Domestic credit (% of GDP) in Congo (Democratic) in 2009 to that in 2010?
Give a very brief answer. 6.15. What is the ratio of the Domestic credit (% of GDP) of Dominican Republic in 2009 to that in 2010?
Ensure brevity in your answer.  1.01. What is the ratio of the Domestic credit (% of GDP) of Thailand in 2009 to that in 2010?
Offer a terse response. 0.96. What is the difference between the highest and the second highest Domestic credit (% of GDP) of Congo (Democratic)?
Your answer should be very brief. 0.84. What is the difference between the highest and the second highest Domestic credit (% of GDP) of Dominican Republic?
Offer a very short reply. 0.52. What is the difference between the highest and the second highest Domestic credit (% of GDP) of Thailand?
Provide a succinct answer. 5.14. What is the difference between the highest and the lowest Domestic credit (% of GDP) in Congo (Democratic)?
Ensure brevity in your answer.  5.24. What is the difference between the highest and the lowest Domestic credit (% of GDP) of Dominican Republic?
Ensure brevity in your answer.  11.98. What is the difference between the highest and the lowest Domestic credit (% of GDP) in Thailand?
Provide a succinct answer. 31.71. 